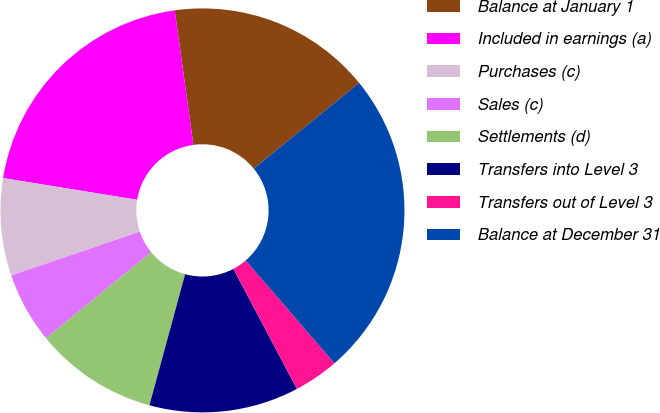<chart> <loc_0><loc_0><loc_500><loc_500><pie_chart><fcel>Balance at January 1<fcel>Included in earnings (a)<fcel>Purchases (c)<fcel>Sales (c)<fcel>Settlements (d)<fcel>Transfers into Level 3<fcel>Transfers out of Level 3<fcel>Balance at December 31<nl><fcel>16.32%<fcel>20.25%<fcel>7.78%<fcel>5.68%<fcel>9.87%<fcel>11.97%<fcel>3.59%<fcel>24.54%<nl></chart> 